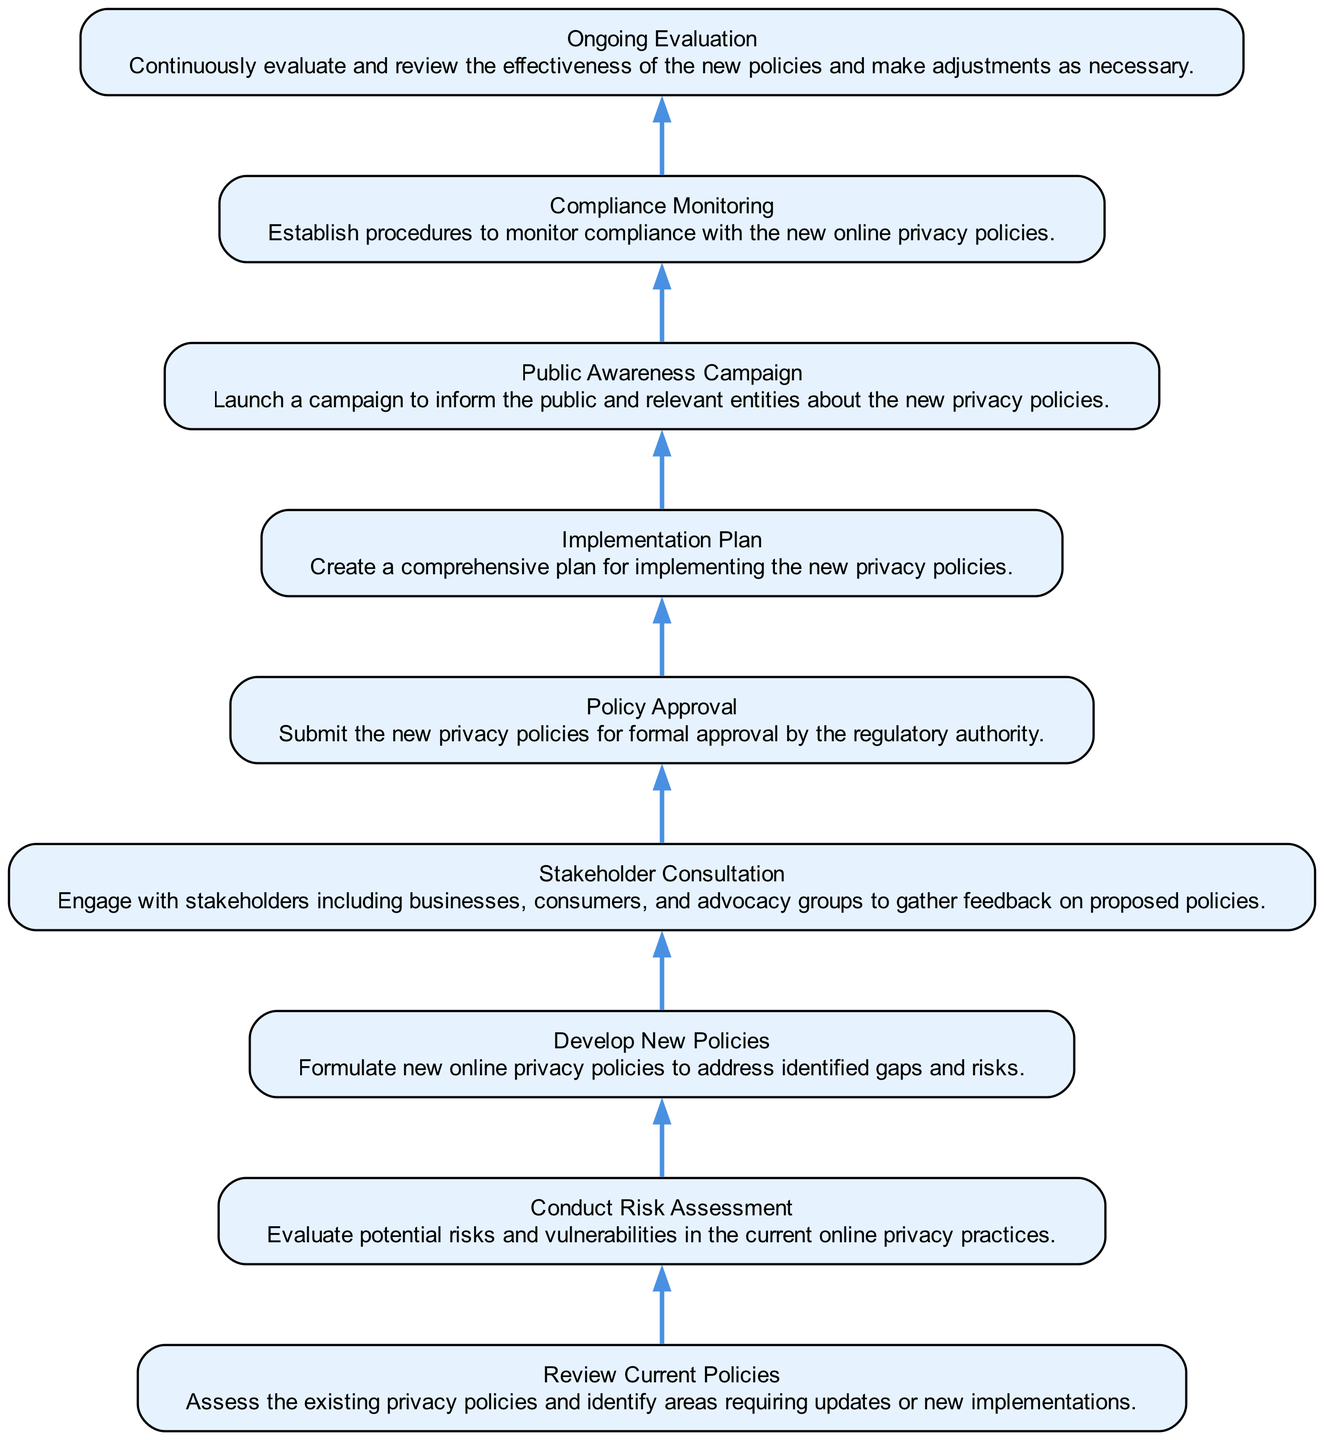What is the first step in the sequence? The first step in the sequence of implementing the new online privacy policies is "Review Current Policies", which is the bottom-most node in the diagram.
Answer: Review Current Policies How many total steps are in the diagram? There are a total of nine steps in the sequence, as represented by the nine nodes in the diagram connected by edges.
Answer: 9 What is the step immediately after "Stakeholder Consultation"? The step that follows "Stakeholder Consultation" in the flow is "Policy Approval", which moves the process closer to finalizing the new policies.
Answer: Policy Approval Which step involves gathering feedback? The step that involves gathering feedback from stakeholders is "Stakeholder Consultation", where various groups provide their inputs on the proposed policies.
Answer: Stakeholder Consultation What is the last step of the implementation process? The last step of the implementation process, shown as the top-most node in the diagram, is "Ongoing Evaluation", which focuses on assessing the policies continuously.
Answer: Ongoing Evaluation What are the first three steps in order? The first three steps according to the flow of the diagram are "Review Current Policies", "Conduct Risk Assessment", and "Develop New Policies", indicating a logical preparatory sequence.
Answer: Review Current Policies, Conduct Risk Assessment, Develop New Policies What action is taken after "Implementation Plan"? After "Implementation Plan", the action taken is to launch a "Public Awareness Campaign" to inform the public and relevant entities about the new policies.
Answer: Public Awareness Campaign Which step focuses on compliance? The step that focuses on compliance with the new policies is "Compliance Monitoring", which establishes procedures to ensure adherence to the privacy regulations implemented.
Answer: Compliance Monitoring What step follows "Policy Approval"? The step that follows "Policy Approval" in the sequence is "Implementation Plan", which outlines how the approved policies will be executed.
Answer: Implementation Plan 